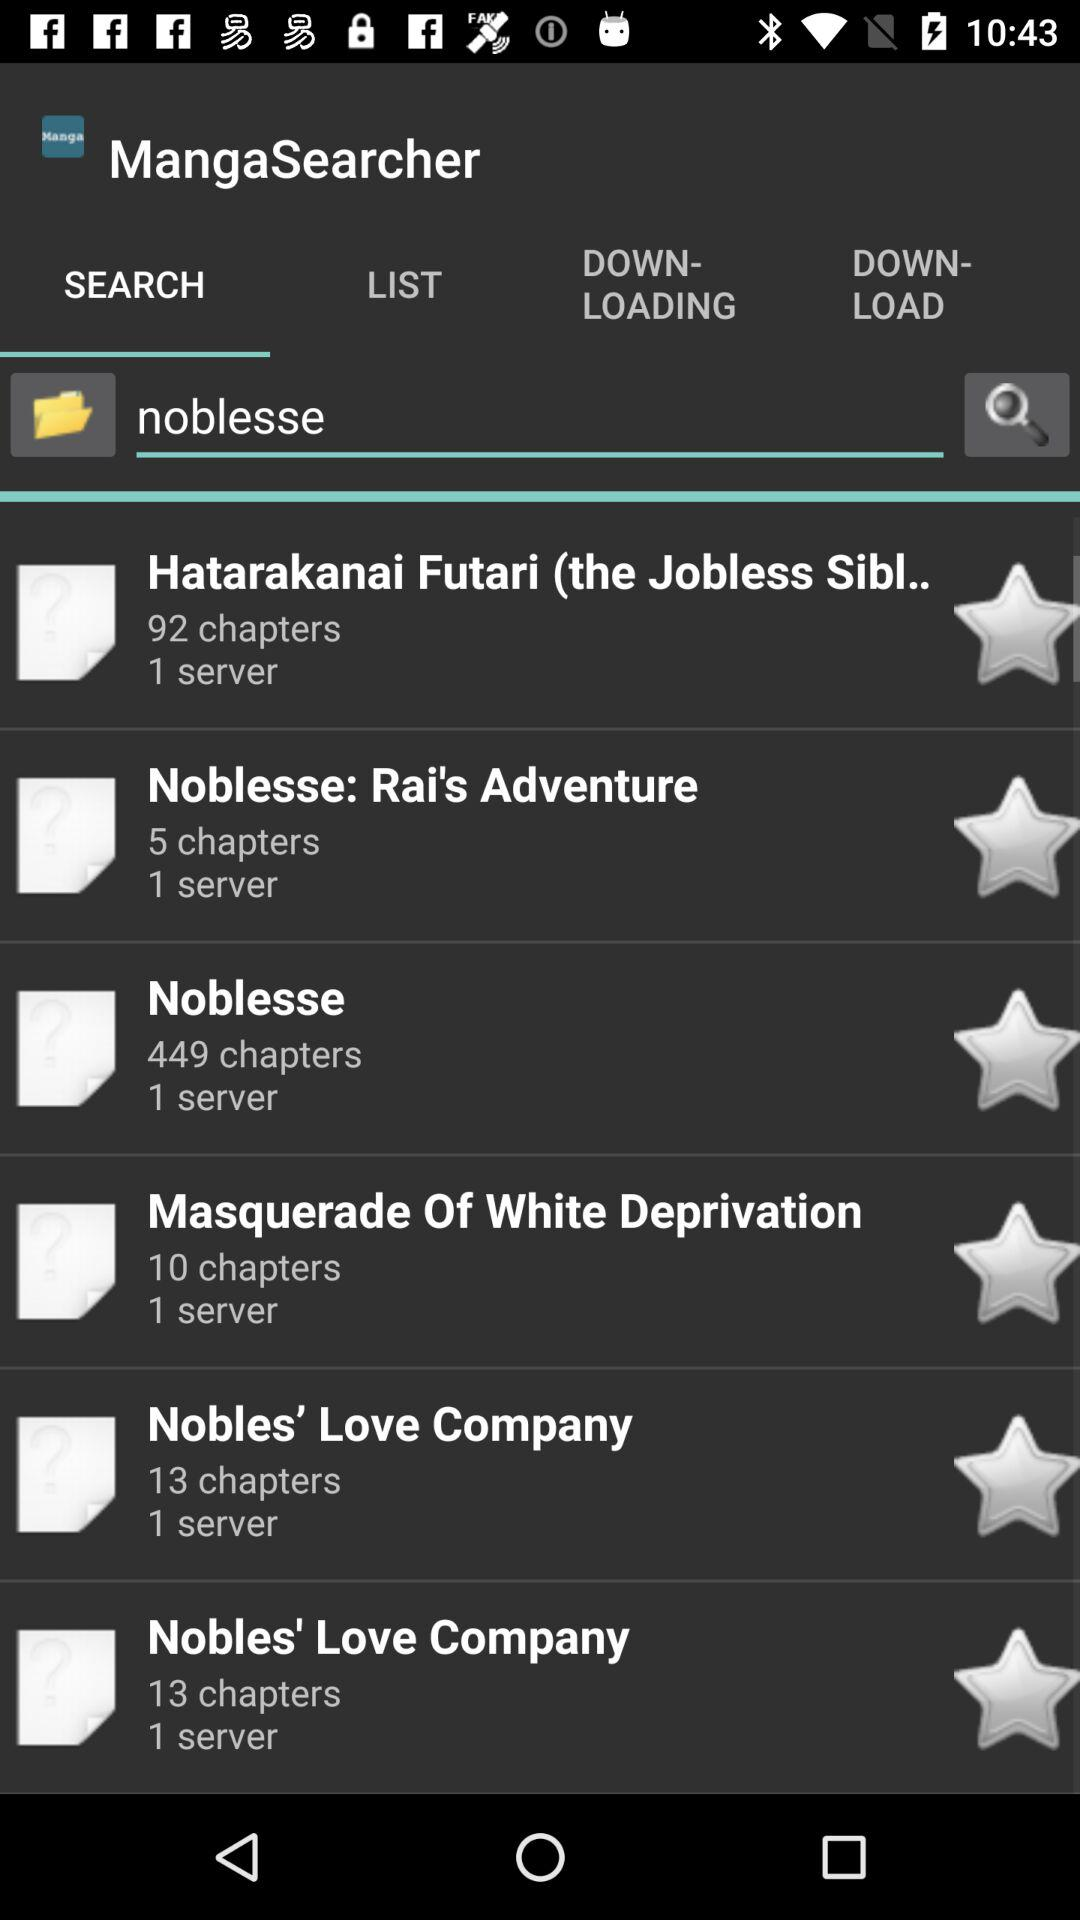How many servers are there for the manga with the least chapters?
Answer the question using a single word or phrase. 1 